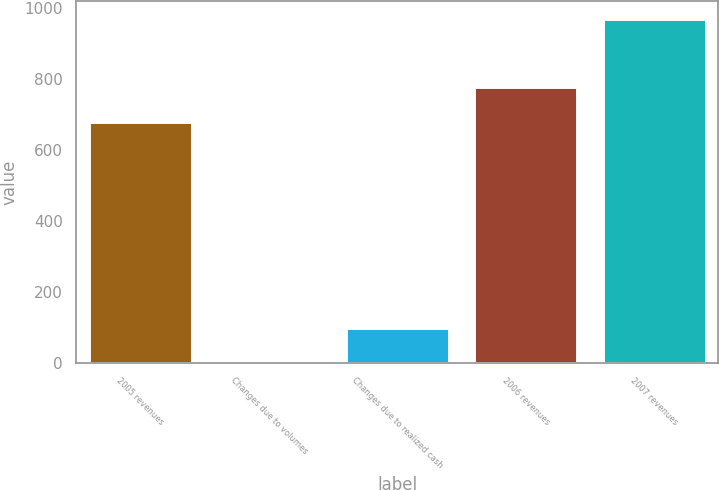<chart> <loc_0><loc_0><loc_500><loc_500><bar_chart><fcel>2005 revenues<fcel>Changes due to volumes<fcel>Changes due to realized cash<fcel>2006 revenues<fcel>2007 revenues<nl><fcel>680<fcel>2<fcel>98.8<fcel>776.8<fcel>970<nl></chart> 